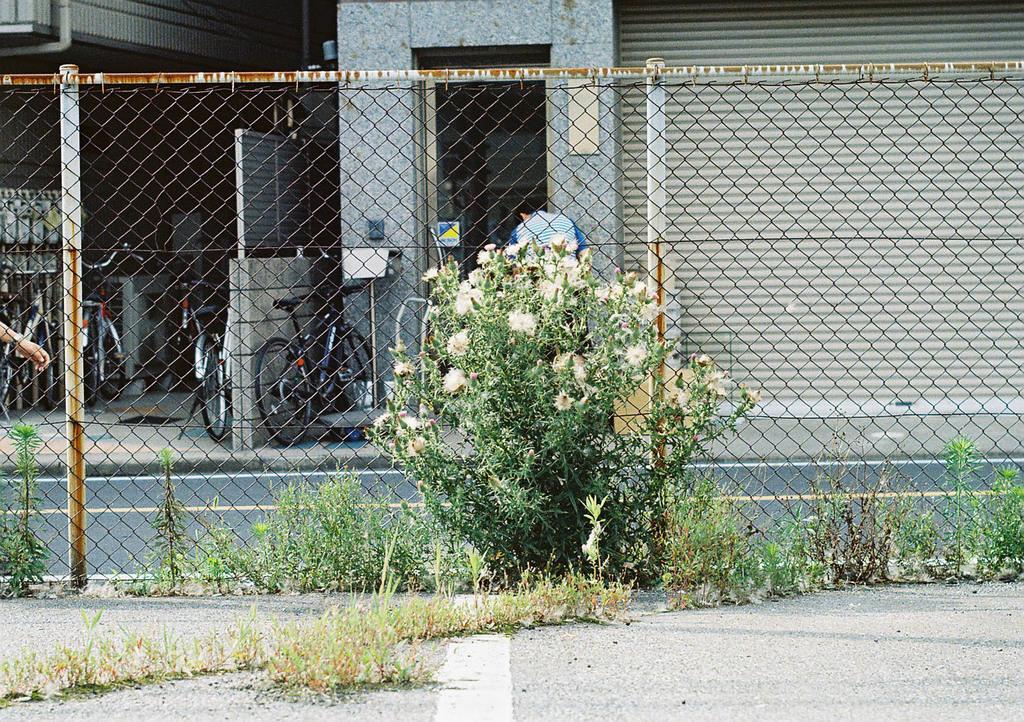In one or two sentences, can you explain what this image depicts? In this picture we can see some plants and flowers in the front, there is fencing in the middle, in the background there are buildings, bicycles, a person and a shutter. 